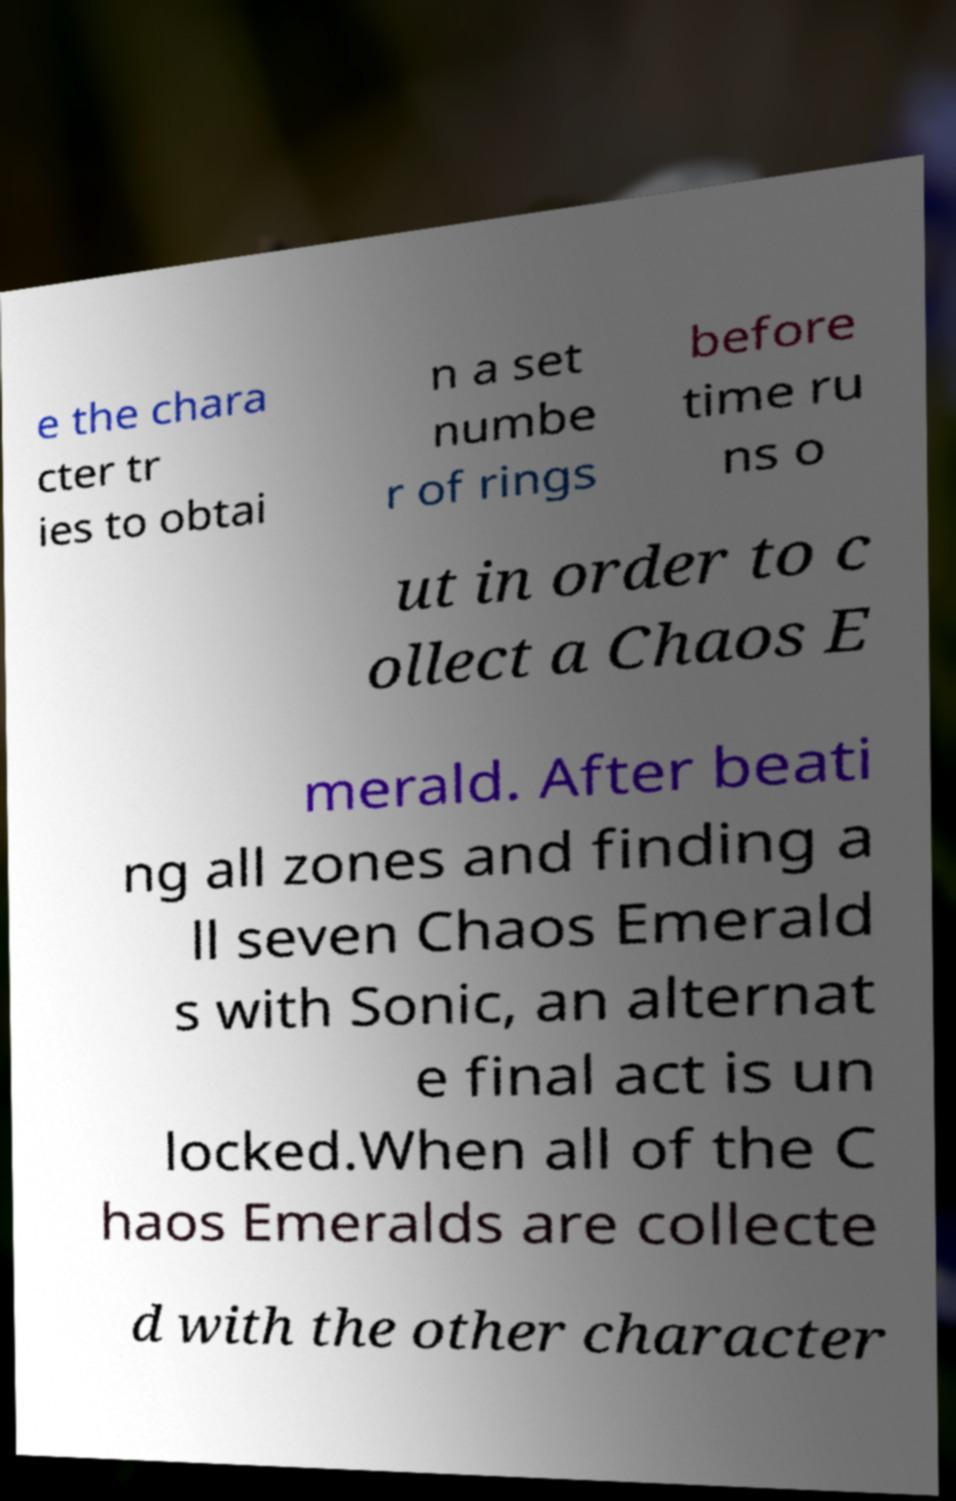Please identify and transcribe the text found in this image. e the chara cter tr ies to obtai n a set numbe r of rings before time ru ns o ut in order to c ollect a Chaos E merald. After beati ng all zones and finding a ll seven Chaos Emerald s with Sonic, an alternat e final act is un locked.When all of the C haos Emeralds are collecte d with the other character 